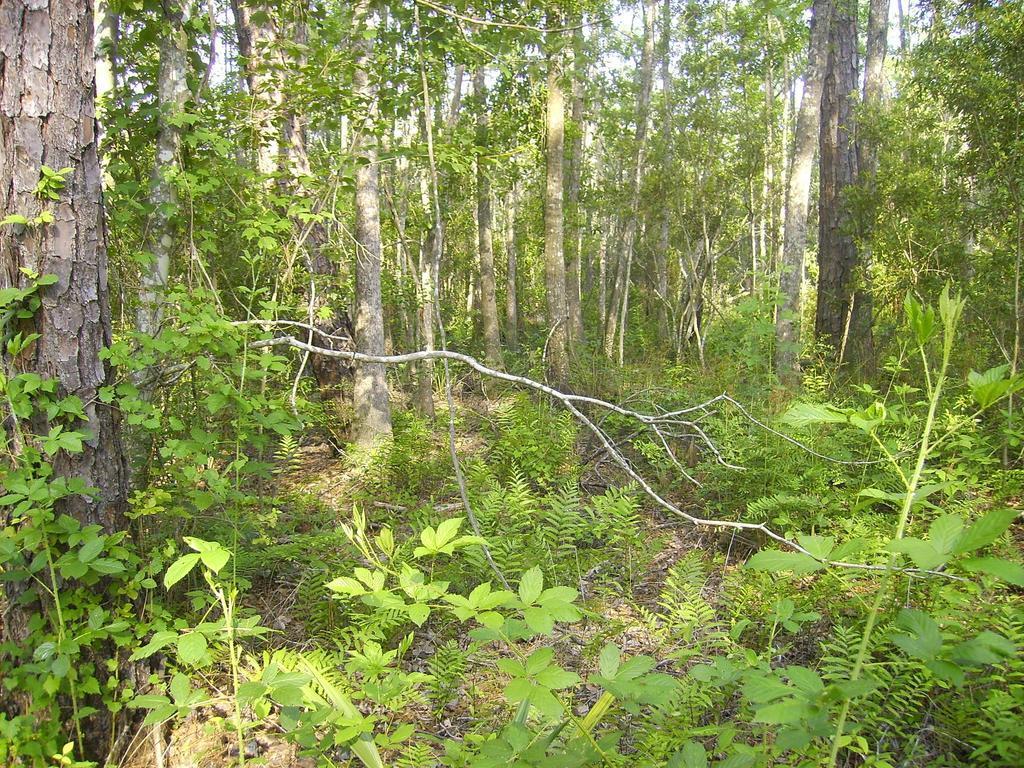Could you give a brief overview of what you see in this image? In this image we can see there are trees and plants. 